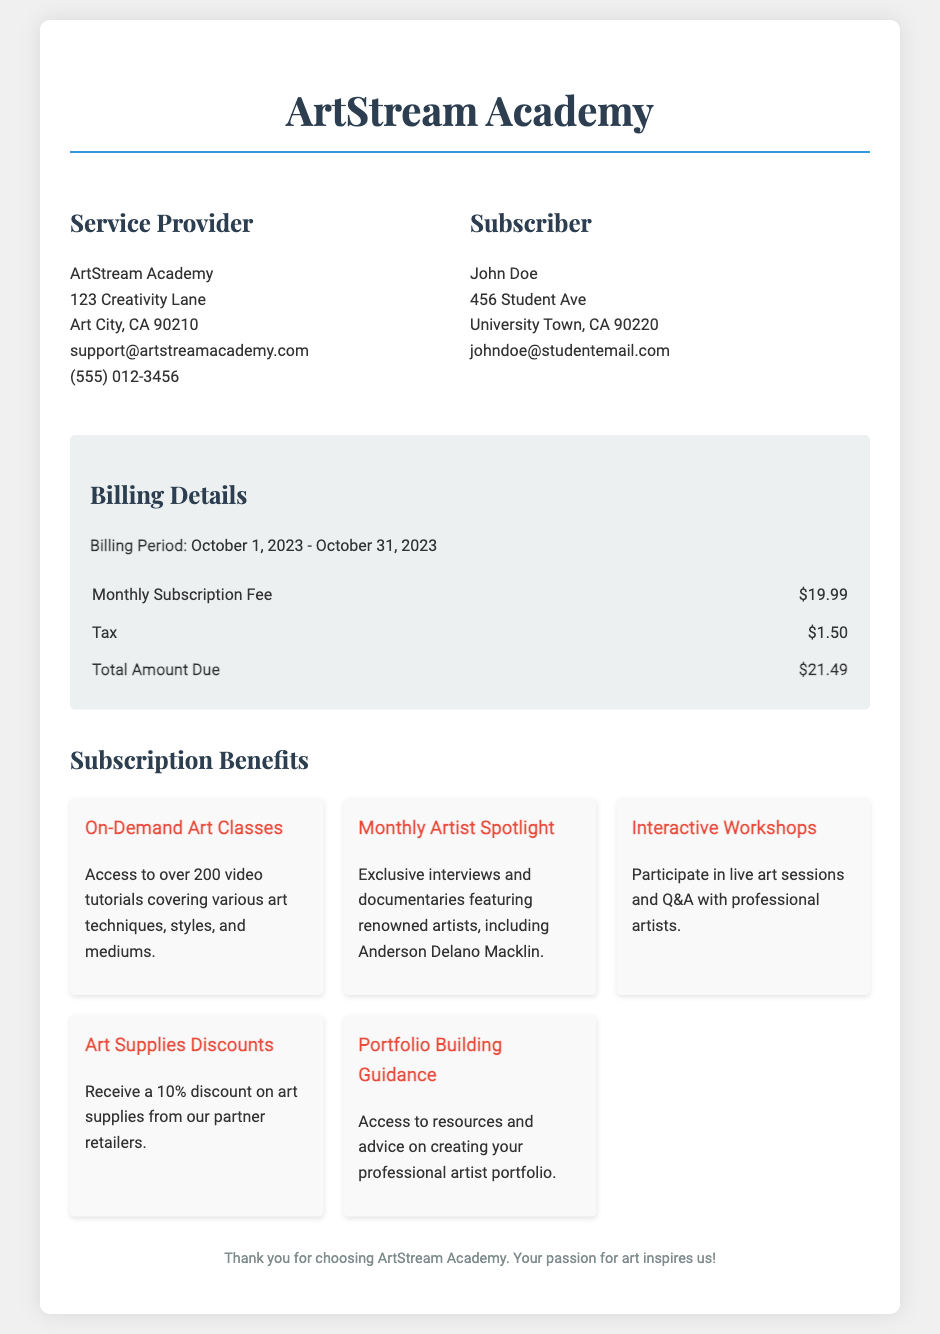What is the name of the service provider? The service provider's name is listed in the document under "Service Provider" as ArtStream Academy.
Answer: ArtStream Academy What is the total amount due? The total amount due is the sum of the monthly subscription fee and tax, which is stated in the billing details.
Answer: $21.49 Who is featured in the Monthly Artist Spotlight? The Monthly Artist Spotlight features exclusive content from renowned artists, including the mentioned artist.
Answer: Anderson Delano Macklin What is the monthly subscription fee? The document specifies the monthly subscription fee under the billing details section, which is clearly itemized.
Answer: $19.99 What benefit offers live sessions with artists? The benefit that involves live interactions is described explicitly in the subscription benefits section of the document.
Answer: Interactive Workshops What discount is provided on art supplies? The document mentions a specific percentage discount on art supplies available to subscribers.
Answer: 10% What is the billing period for the current bill? The billing period is mentioned in the billing details section, covering specific start and end dates.
Answer: October 1, 2023 - October 31, 2023 How many video tutorials are accessible to subscribers? The number of video tutorials available is included in the description of one of the subscription benefits.
Answer: over 200 What can subscribers access regarding portfolio building? The portfolio building guidance mentions resources and advice for creating a specific type of professional document.
Answer: professional artist portfolio 